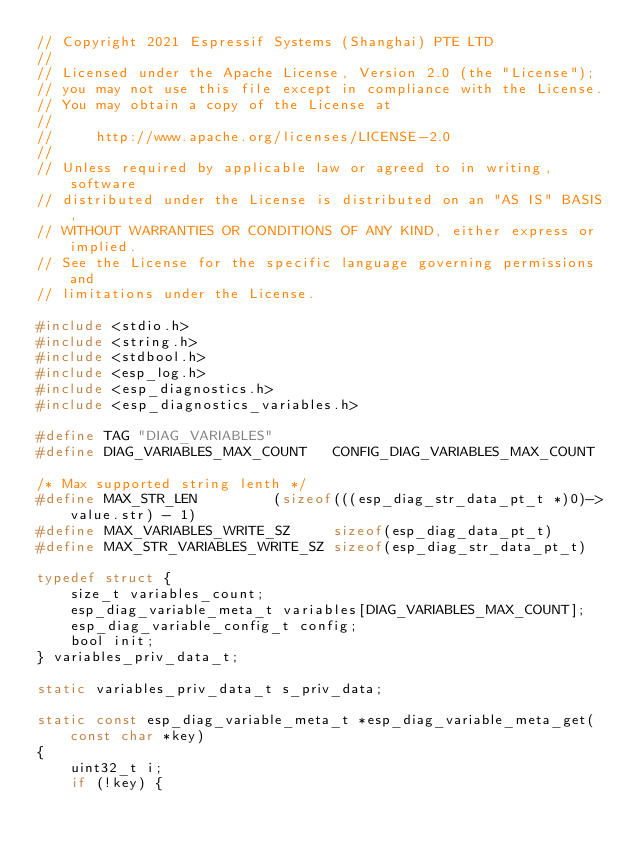<code> <loc_0><loc_0><loc_500><loc_500><_C_>// Copyright 2021 Espressif Systems (Shanghai) PTE LTD
//
// Licensed under the Apache License, Version 2.0 (the "License");
// you may not use this file except in compliance with the License.
// You may obtain a copy of the License at
//
//     http://www.apache.org/licenses/LICENSE-2.0
//
// Unless required by applicable law or agreed to in writing, software
// distributed under the License is distributed on an "AS IS" BASIS,
// WITHOUT WARRANTIES OR CONDITIONS OF ANY KIND, either express or implied.
// See the License for the specific language governing permissions and
// limitations under the License.

#include <stdio.h>
#include <string.h>
#include <stdbool.h>
#include <esp_log.h>
#include <esp_diagnostics.h>
#include <esp_diagnostics_variables.h>

#define TAG "DIAG_VARIABLES"
#define DIAG_VARIABLES_MAX_COUNT   CONFIG_DIAG_VARIABLES_MAX_COUNT

/* Max supported string lenth */
#define MAX_STR_LEN         (sizeof(((esp_diag_str_data_pt_t *)0)->value.str) - 1)
#define MAX_VARIABLES_WRITE_SZ     sizeof(esp_diag_data_pt_t)
#define MAX_STR_VARIABLES_WRITE_SZ sizeof(esp_diag_str_data_pt_t)

typedef struct {
    size_t variables_count;
    esp_diag_variable_meta_t variables[DIAG_VARIABLES_MAX_COUNT];
    esp_diag_variable_config_t config;
    bool init;
} variables_priv_data_t;

static variables_priv_data_t s_priv_data;

static const esp_diag_variable_meta_t *esp_diag_variable_meta_get(const char *key)
{
    uint32_t i;
    if (!key) {</code> 